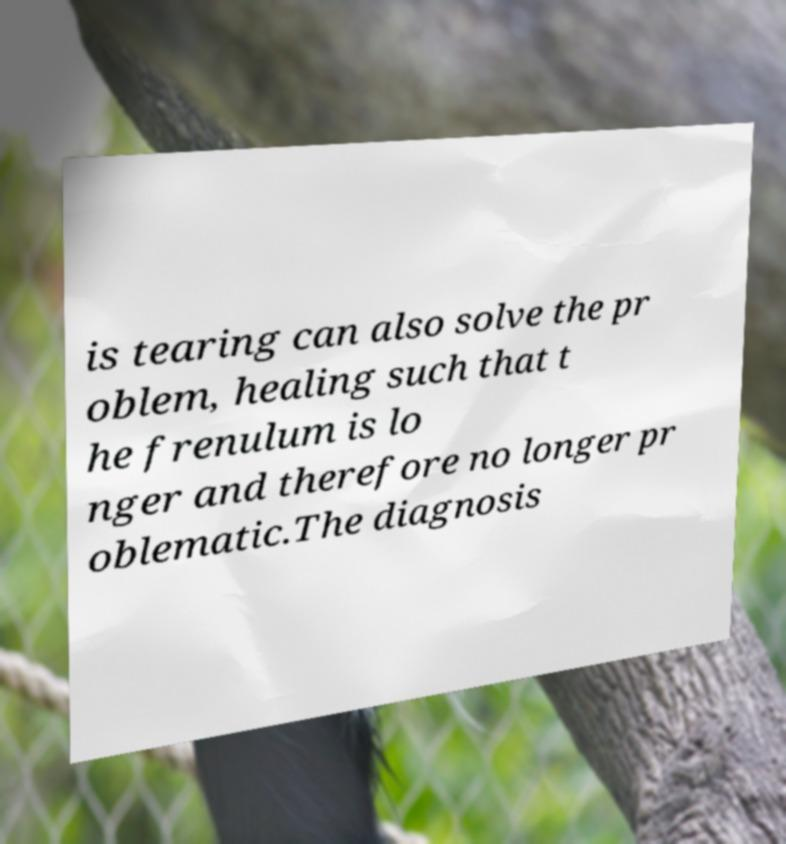There's text embedded in this image that I need extracted. Can you transcribe it verbatim? is tearing can also solve the pr oblem, healing such that t he frenulum is lo nger and therefore no longer pr oblematic.The diagnosis 